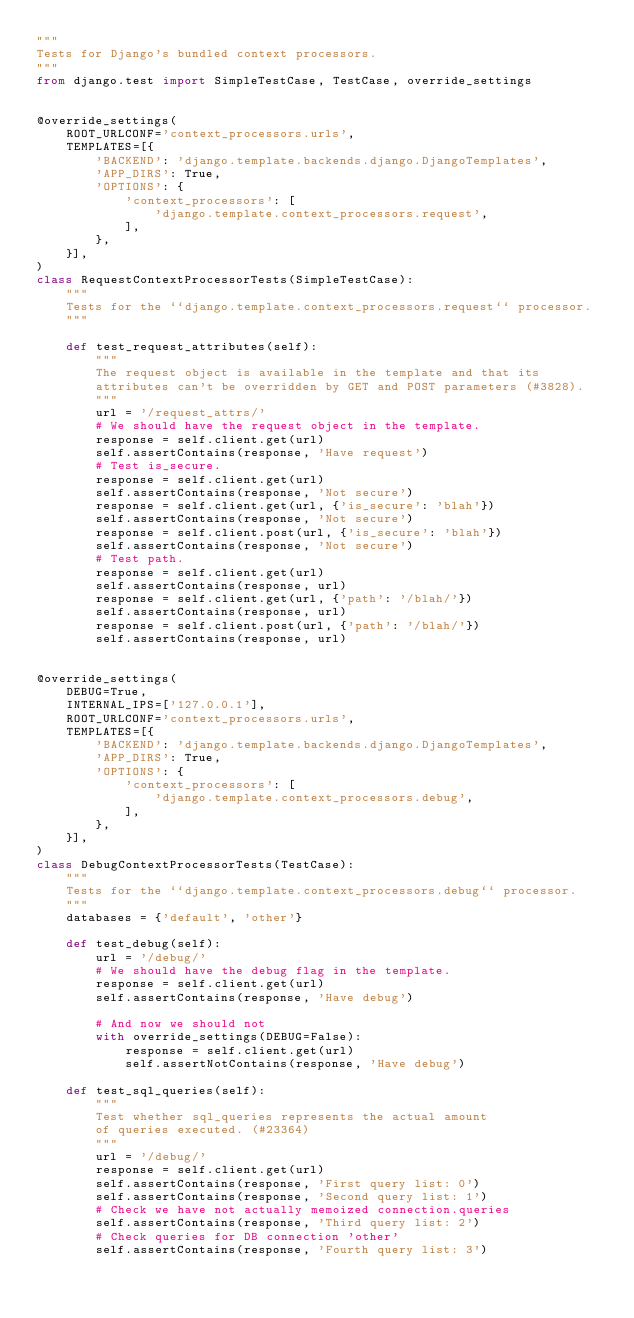Convert code to text. <code><loc_0><loc_0><loc_500><loc_500><_Python_>"""
Tests for Django's bundled context processors.
"""
from django.test import SimpleTestCase, TestCase, override_settings


@override_settings(
    ROOT_URLCONF='context_processors.urls',
    TEMPLATES=[{
        'BACKEND': 'django.template.backends.django.DjangoTemplates',
        'APP_DIRS': True,
        'OPTIONS': {
            'context_processors': [
                'django.template.context_processors.request',
            ],
        },
    }],
)
class RequestContextProcessorTests(SimpleTestCase):
    """
    Tests for the ``django.template.context_processors.request`` processor.
    """

    def test_request_attributes(self):
        """
        The request object is available in the template and that its
        attributes can't be overridden by GET and POST parameters (#3828).
        """
        url = '/request_attrs/'
        # We should have the request object in the template.
        response = self.client.get(url)
        self.assertContains(response, 'Have request')
        # Test is_secure.
        response = self.client.get(url)
        self.assertContains(response, 'Not secure')
        response = self.client.get(url, {'is_secure': 'blah'})
        self.assertContains(response, 'Not secure')
        response = self.client.post(url, {'is_secure': 'blah'})
        self.assertContains(response, 'Not secure')
        # Test path.
        response = self.client.get(url)
        self.assertContains(response, url)
        response = self.client.get(url, {'path': '/blah/'})
        self.assertContains(response, url)
        response = self.client.post(url, {'path': '/blah/'})
        self.assertContains(response, url)


@override_settings(
    DEBUG=True,
    INTERNAL_IPS=['127.0.0.1'],
    ROOT_URLCONF='context_processors.urls',
    TEMPLATES=[{
        'BACKEND': 'django.template.backends.django.DjangoTemplates',
        'APP_DIRS': True,
        'OPTIONS': {
            'context_processors': [
                'django.template.context_processors.debug',
            ],
        },
    }],
)
class DebugContextProcessorTests(TestCase):
    """
    Tests for the ``django.template.context_processors.debug`` processor.
    """
    databases = {'default', 'other'}

    def test_debug(self):
        url = '/debug/'
        # We should have the debug flag in the template.
        response = self.client.get(url)
        self.assertContains(response, 'Have debug')

        # And now we should not
        with override_settings(DEBUG=False):
            response = self.client.get(url)
            self.assertNotContains(response, 'Have debug')

    def test_sql_queries(self):
        """
        Test whether sql_queries represents the actual amount
        of queries executed. (#23364)
        """
        url = '/debug/'
        response = self.client.get(url)
        self.assertContains(response, 'First query list: 0')
        self.assertContains(response, 'Second query list: 1')
        # Check we have not actually memoized connection.queries
        self.assertContains(response, 'Third query list: 2')
        # Check queries for DB connection 'other'
        self.assertContains(response, 'Fourth query list: 3')
</code> 